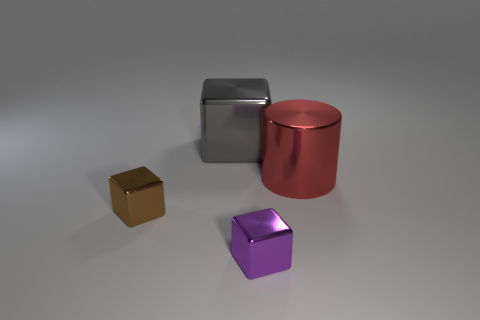Subtract all large gray metal cubes. How many cubes are left? 2 Subtract all purple blocks. How many blocks are left? 2 Add 4 yellow metallic cylinders. How many objects exist? 8 Subtract all blocks. How many objects are left? 1 Subtract 1 cylinders. How many cylinders are left? 0 Subtract all yellow blocks. Subtract all brown cylinders. How many blocks are left? 3 Subtract all red blocks. How many gray cylinders are left? 0 Subtract all green rubber objects. Subtract all tiny purple things. How many objects are left? 3 Add 2 brown shiny cubes. How many brown shiny cubes are left? 3 Add 1 large gray shiny things. How many large gray shiny things exist? 2 